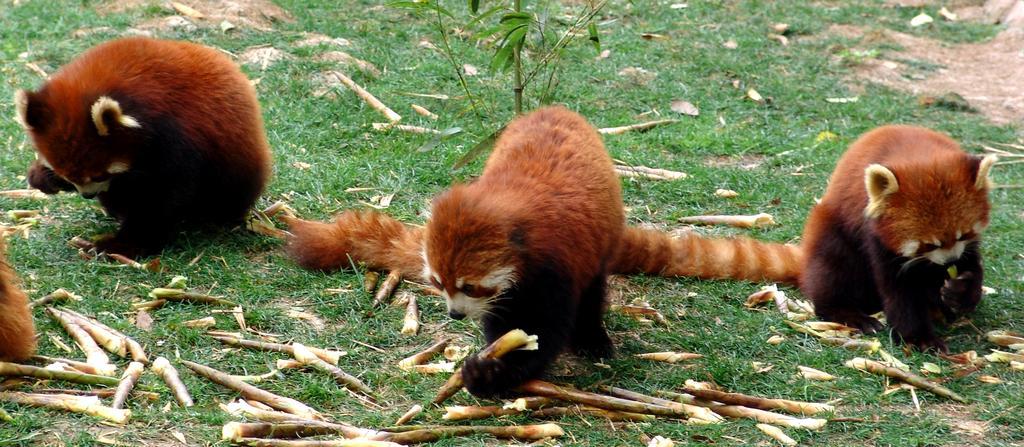Can you describe this image briefly? In this image we can see the animals on the ground, there is a plant, grass and some objects on the ground. 